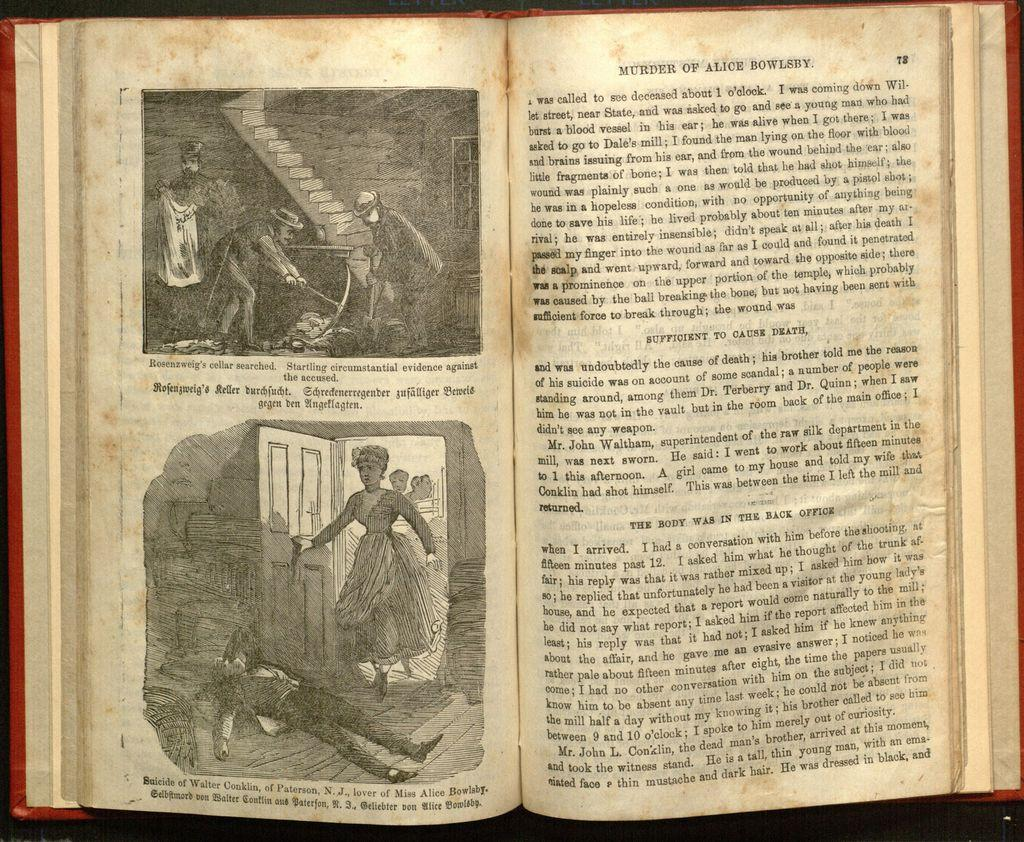<image>
Provide a brief description of the given image. A older book with the chapter titled Murder of Alice Bowlsby. 